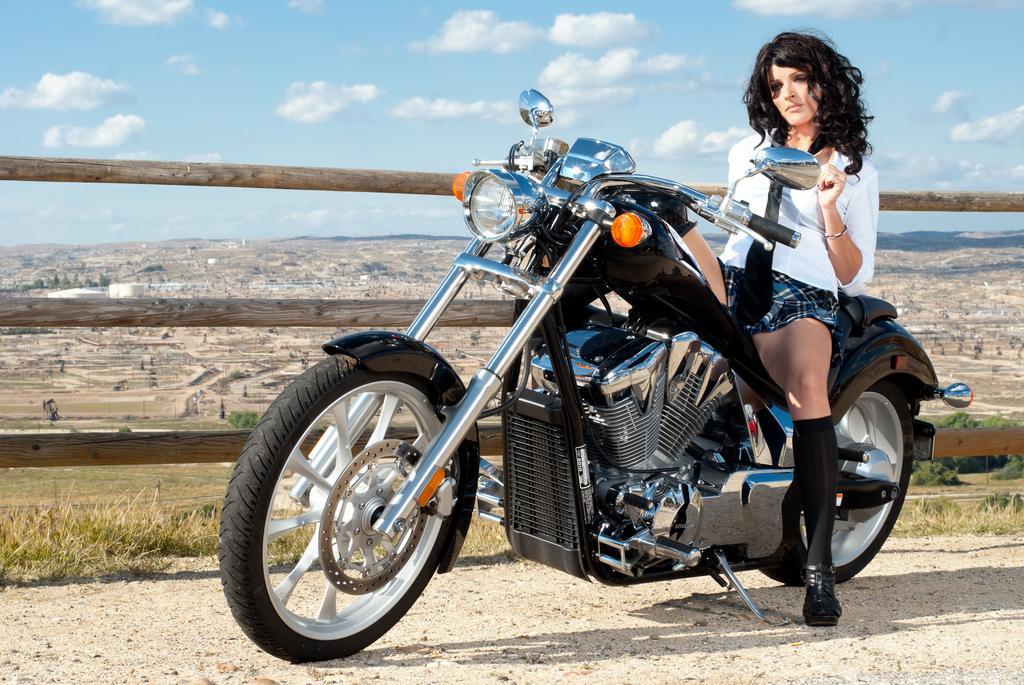Could you give a brief overview of what you see in this image? we can see in the picture that a women is sitting on a bike, she is wearing white shirt and a skirt. These are the wheels,grass and sky. This is wooden fencing. 